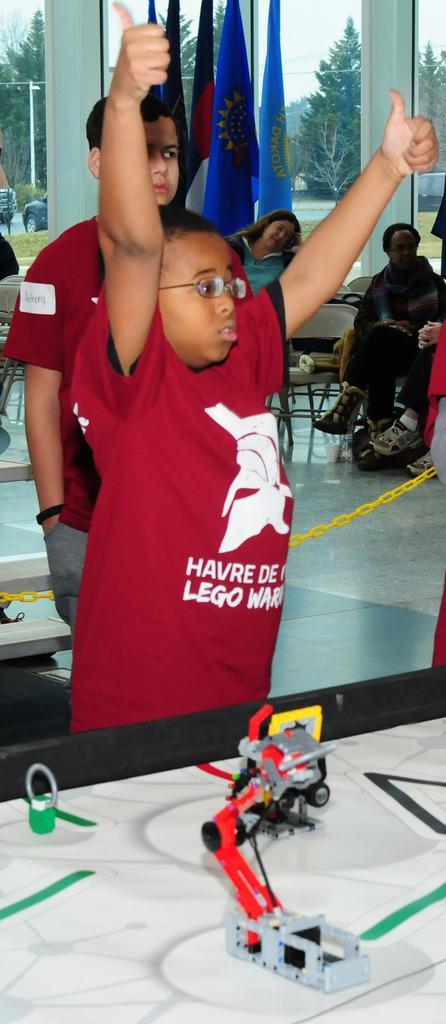Describe this image in one or two sentences. At the bottom of the image there is a white surface with toys. Behind that there is a boy with maroon t-shirt is standing. Behind him there is another boy standing. In the background there are few people sitting on the chairs and also there are flags. Behind the flags there are glass doors. Behind the doors there are trees and vehicles on the road. 